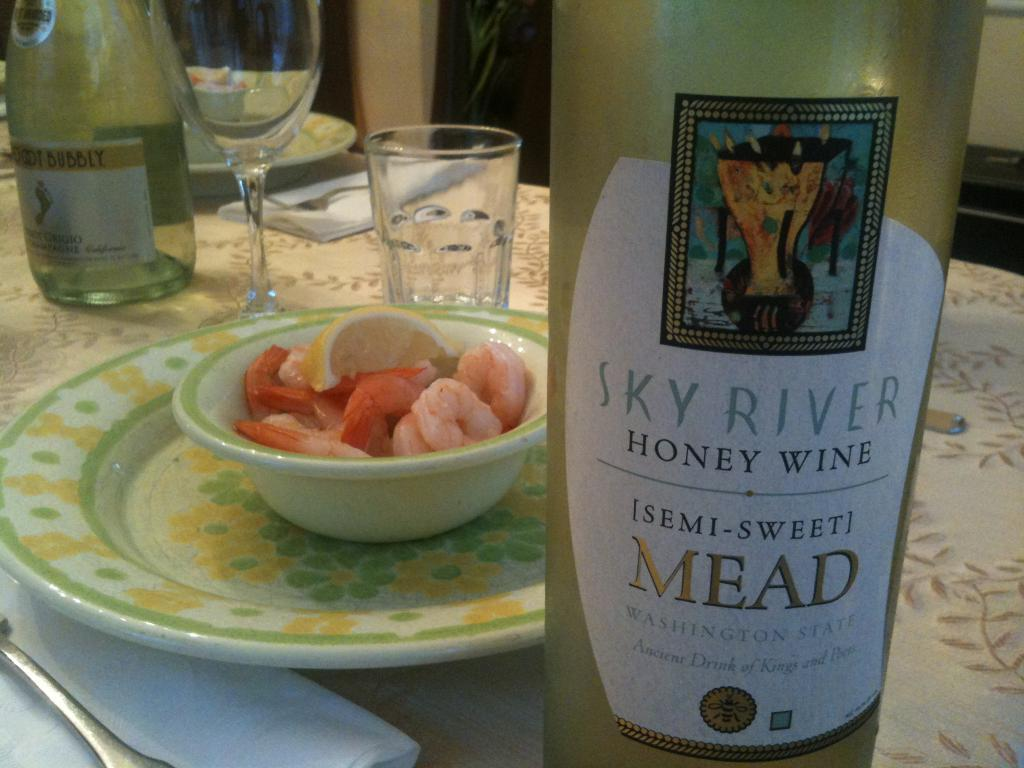<image>
Give a short and clear explanation of the subsequent image. A bottle of semi-sweet honey wine mead made by Sky River. 